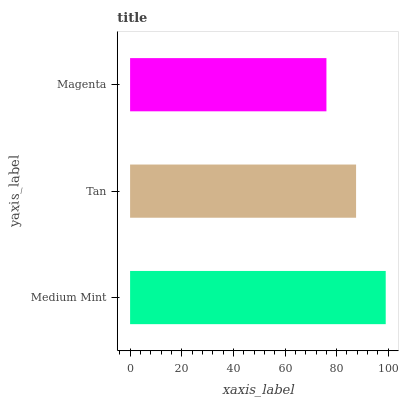Is Magenta the minimum?
Answer yes or no. Yes. Is Medium Mint the maximum?
Answer yes or no. Yes. Is Tan the minimum?
Answer yes or no. No. Is Tan the maximum?
Answer yes or no. No. Is Medium Mint greater than Tan?
Answer yes or no. Yes. Is Tan less than Medium Mint?
Answer yes or no. Yes. Is Tan greater than Medium Mint?
Answer yes or no. No. Is Medium Mint less than Tan?
Answer yes or no. No. Is Tan the high median?
Answer yes or no. Yes. Is Tan the low median?
Answer yes or no. Yes. Is Magenta the high median?
Answer yes or no. No. Is Magenta the low median?
Answer yes or no. No. 